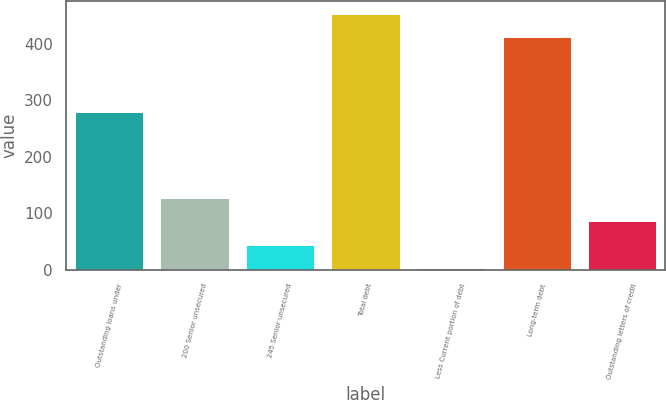<chart> <loc_0><loc_0><loc_500><loc_500><bar_chart><fcel>Outstanding loans under<fcel>200 Senior unsecured<fcel>245 Senior unsecured<fcel>Total debt<fcel>Less Current portion of debt<fcel>Long-term debt<fcel>Outstanding letters of credit<nl><fcel>280<fcel>126.6<fcel>44.2<fcel>453.2<fcel>3<fcel>412<fcel>85.4<nl></chart> 